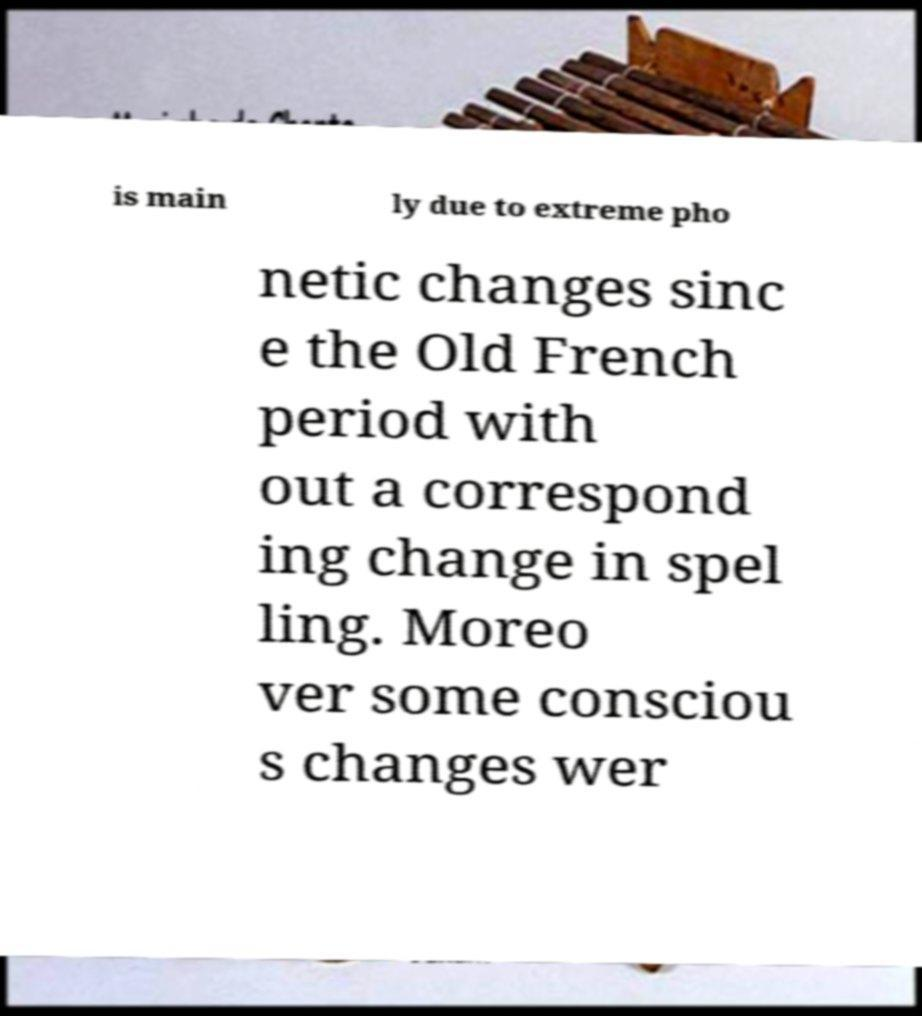What messages or text are displayed in this image? I need them in a readable, typed format. is main ly due to extreme pho netic changes sinc e the Old French period with out a correspond ing change in spel ling. Moreo ver some consciou s changes wer 